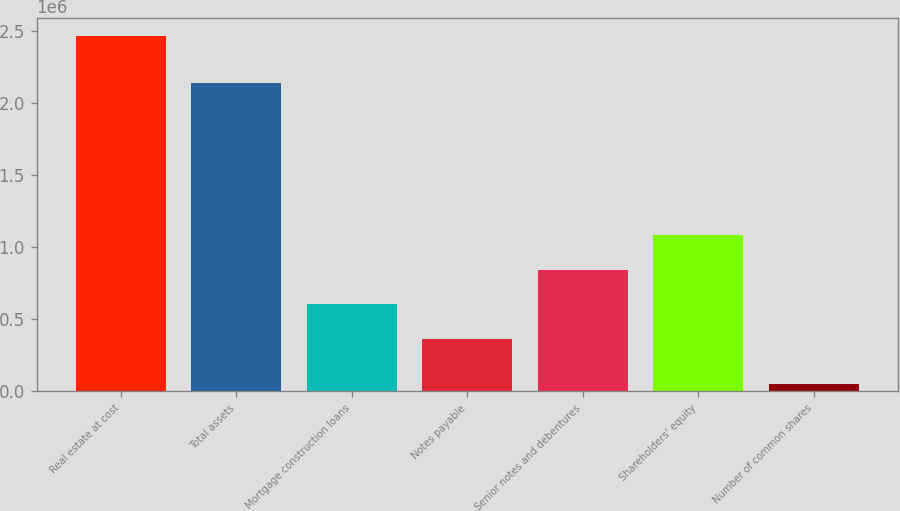Convert chart. <chart><loc_0><loc_0><loc_500><loc_500><bar_chart><fcel>Real estate at cost<fcel>Total assets<fcel>Mortgage construction loans<fcel>Notes payable<fcel>Senior notes and debentures<fcel>Shareholders' equity<fcel>Number of common shares<nl><fcel>2.47015e+06<fcel>2.14118e+06<fcel>603418<fcel>361323<fcel>845513<fcel>1.08761e+06<fcel>49201<nl></chart> 